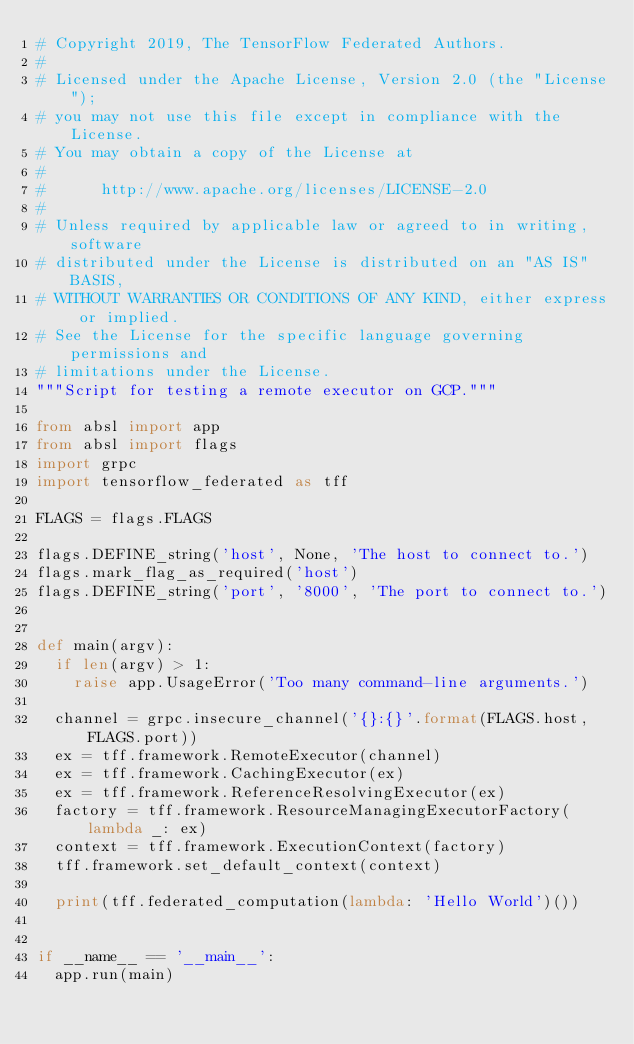Convert code to text. <code><loc_0><loc_0><loc_500><loc_500><_Python_># Copyright 2019, The TensorFlow Federated Authors.
#
# Licensed under the Apache License, Version 2.0 (the "License");
# you may not use this file except in compliance with the License.
# You may obtain a copy of the License at
#
#      http://www.apache.org/licenses/LICENSE-2.0
#
# Unless required by applicable law or agreed to in writing, software
# distributed under the License is distributed on an "AS IS" BASIS,
# WITHOUT WARRANTIES OR CONDITIONS OF ANY KIND, either express or implied.
# See the License for the specific language governing permissions and
# limitations under the License.
"""Script for testing a remote executor on GCP."""

from absl import app
from absl import flags
import grpc
import tensorflow_federated as tff

FLAGS = flags.FLAGS

flags.DEFINE_string('host', None, 'The host to connect to.')
flags.mark_flag_as_required('host')
flags.DEFINE_string('port', '8000', 'The port to connect to.')


def main(argv):
  if len(argv) > 1:
    raise app.UsageError('Too many command-line arguments.')

  channel = grpc.insecure_channel('{}:{}'.format(FLAGS.host, FLAGS.port))
  ex = tff.framework.RemoteExecutor(channel)
  ex = tff.framework.CachingExecutor(ex)
  ex = tff.framework.ReferenceResolvingExecutor(ex)
  factory = tff.framework.ResourceManagingExecutorFactory(lambda _: ex)
  context = tff.framework.ExecutionContext(factory)
  tff.framework.set_default_context(context)

  print(tff.federated_computation(lambda: 'Hello World')())


if __name__ == '__main__':
  app.run(main)
</code> 